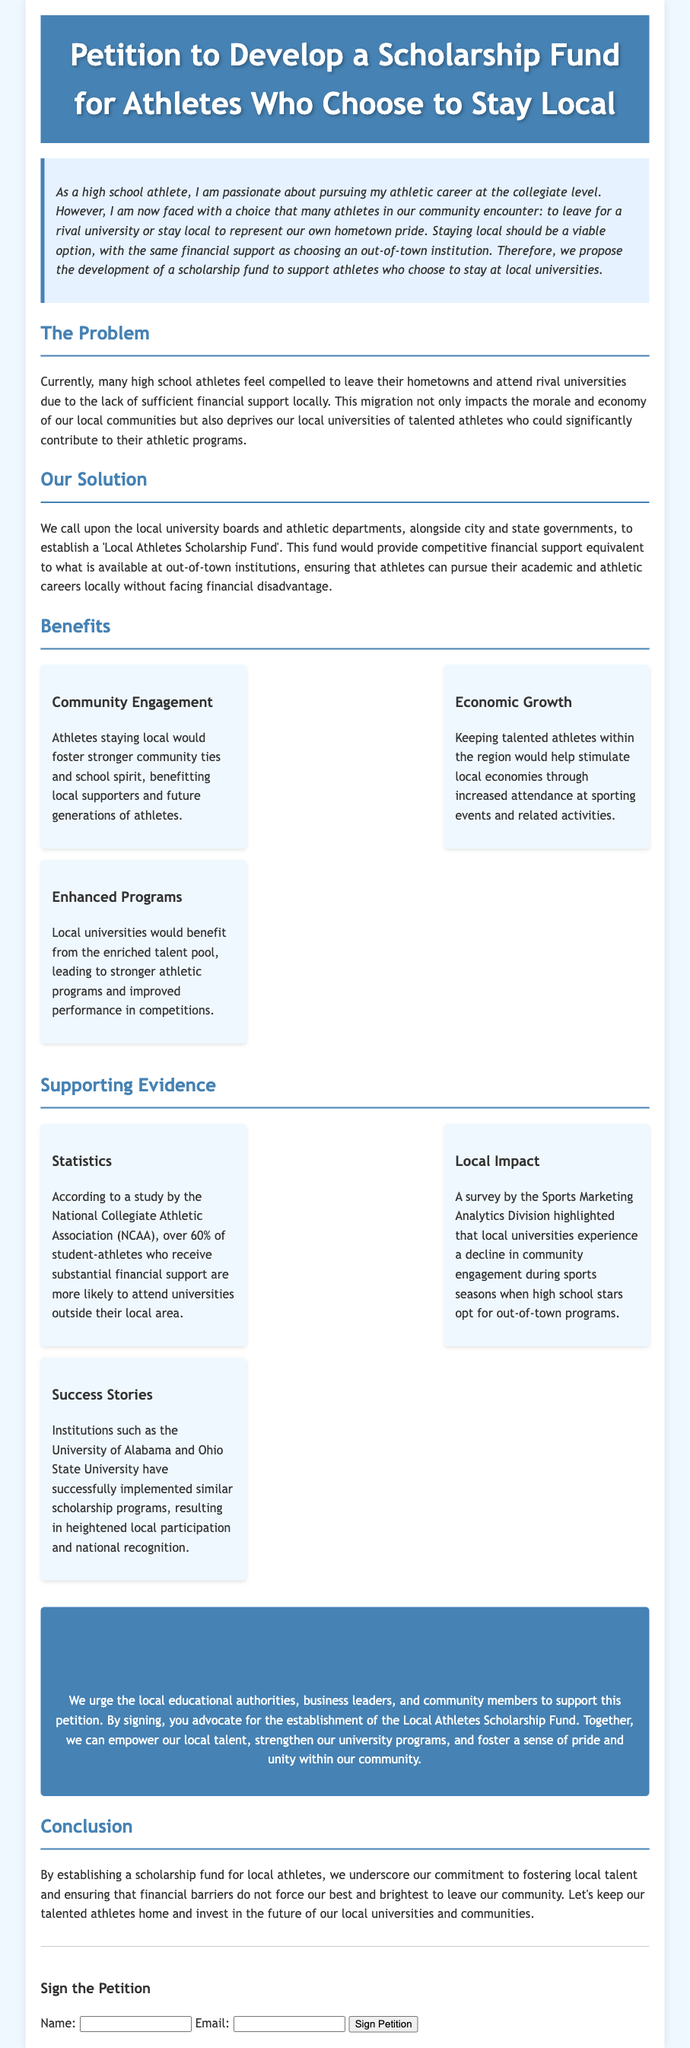What is the title of the petition? The title of the petition is prominently displayed at the top of the document.
Answer: Petition to Develop a Scholarship Fund for Athletes Who Choose to Stay Local What section addresses the current issue faced by local athletes? The document explicitly has a section that discusses the problem local athletes face.
Answer: The Problem What is the proposed solution mentioned in the petition? The petition suggests a specific action to be taken by local entities to support athletes.
Answer: Local Athletes Scholarship Fund What percentage of student-athletes is mentioned in relation to financial support? The petition references a statistic regarding student-athletes and their decisions based on financial aid.
Answer: 60% What are the three main benefits listed in the petition? The document outlines specific advantages of establishing the scholarship fund.
Answer: Community Engagement, Economic Growth, Enhanced Programs What is the overall purpose of this petition? The intent behind the petition is summarized in its introductory paragraph.
Answer: To support athletes who choose to stay local Who is urged to support the petition? The petition calls for a variety of community stakeholders to get involved.
Answer: Local educational authorities, business leaders, and community members What type of support does the scholarship fund aim to provide? The petition specifies the nature of financial assistance it is proposing.
Answer: Competitive financial support 